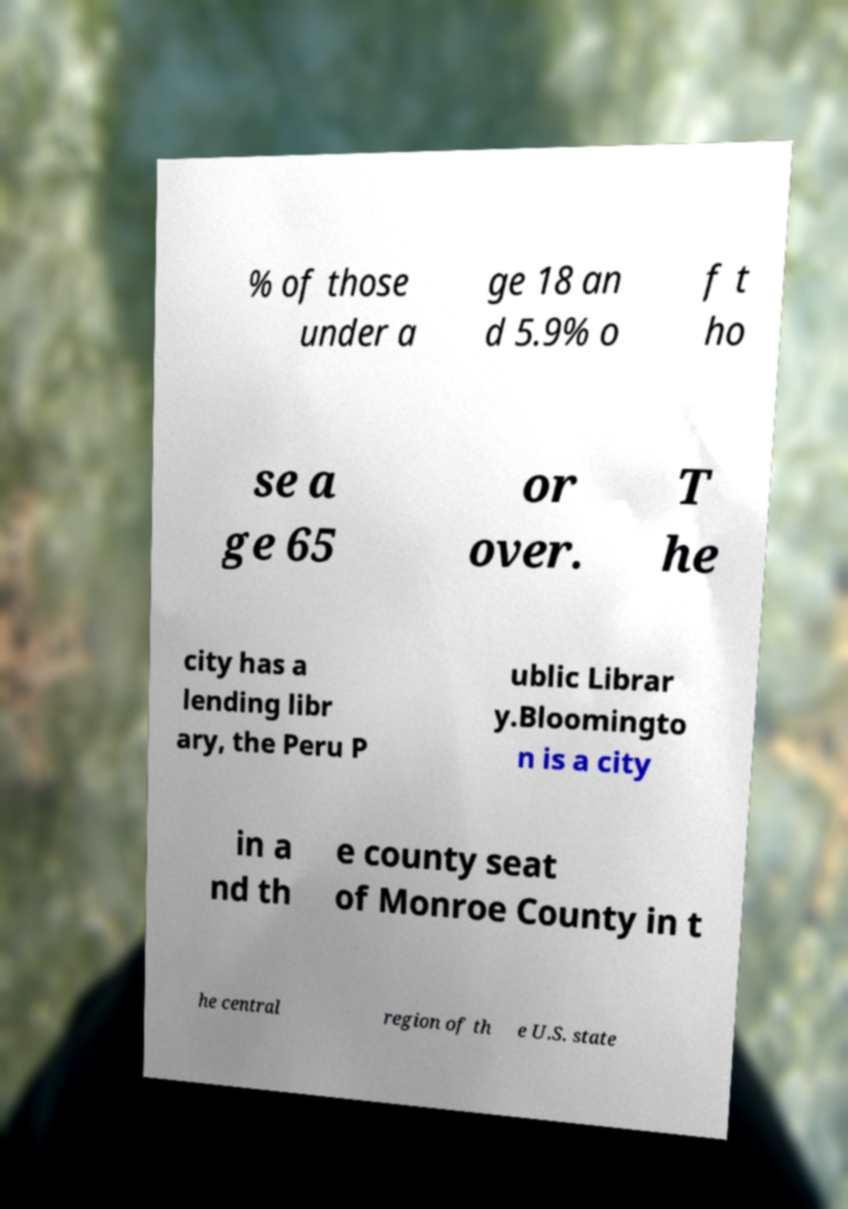What messages or text are displayed in this image? I need them in a readable, typed format. % of those under a ge 18 an d 5.9% o f t ho se a ge 65 or over. T he city has a lending libr ary, the Peru P ublic Librar y.Bloomingto n is a city in a nd th e county seat of Monroe County in t he central region of th e U.S. state 